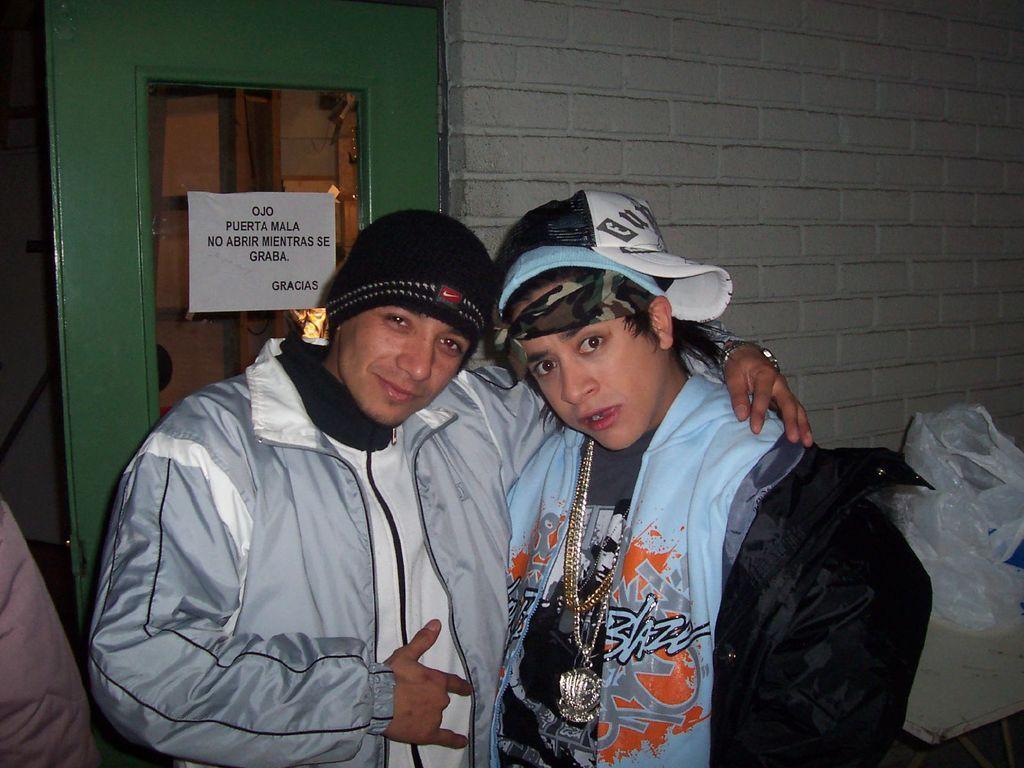How would you summarize this image in a sentence or two? In this image I can see two persons wearing jackets and caps are standing. In the background I an see the green colored door, a paper attached to the door, the white colored wall and a plastic bag. 